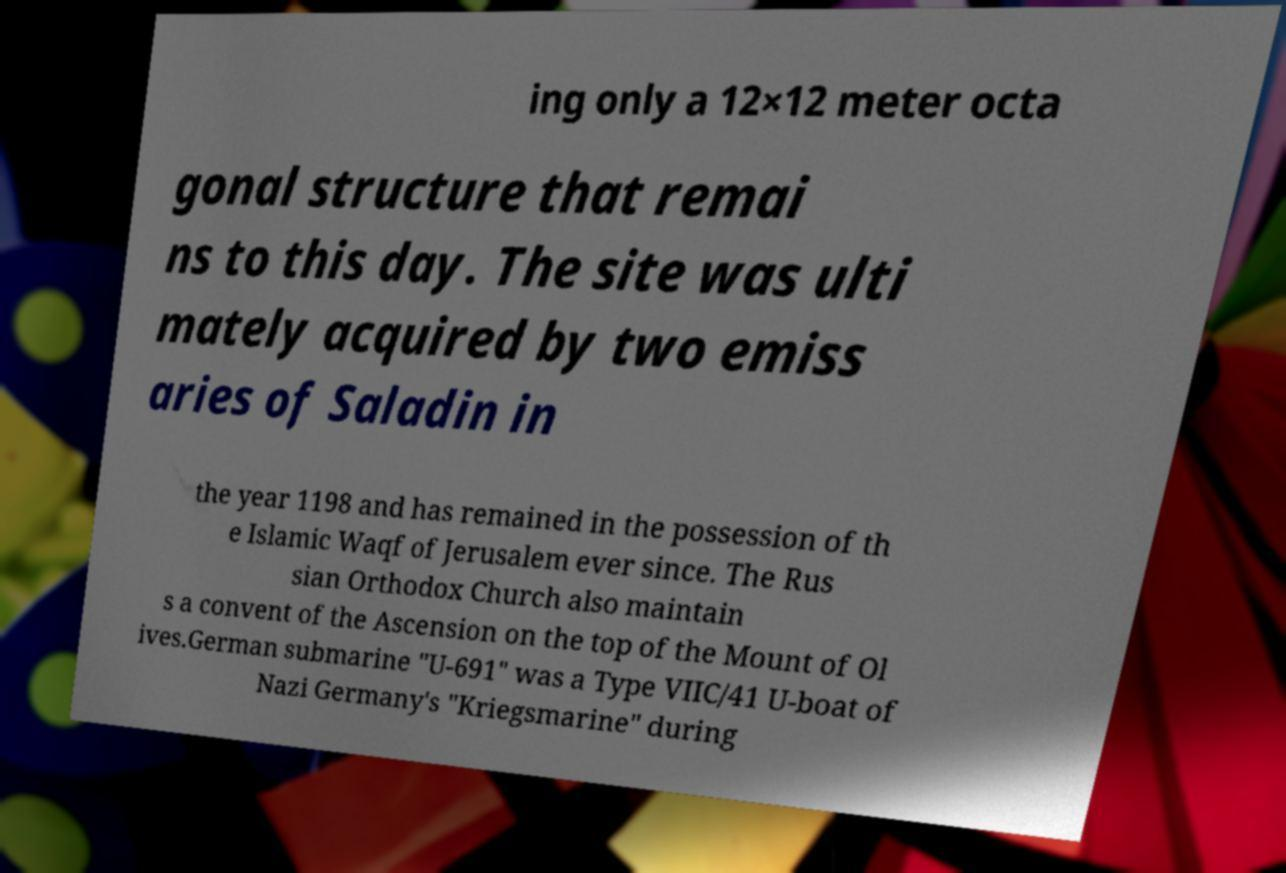I need the written content from this picture converted into text. Can you do that? ing only a 12×12 meter octa gonal structure that remai ns to this day. The site was ulti mately acquired by two emiss aries of Saladin in the year 1198 and has remained in the possession of th e Islamic Waqf of Jerusalem ever since. The Rus sian Orthodox Church also maintain s a convent of the Ascension on the top of the Mount of Ol ives.German submarine "U-691" was a Type VIIC/41 U-boat of Nazi Germany's "Kriegsmarine" during 